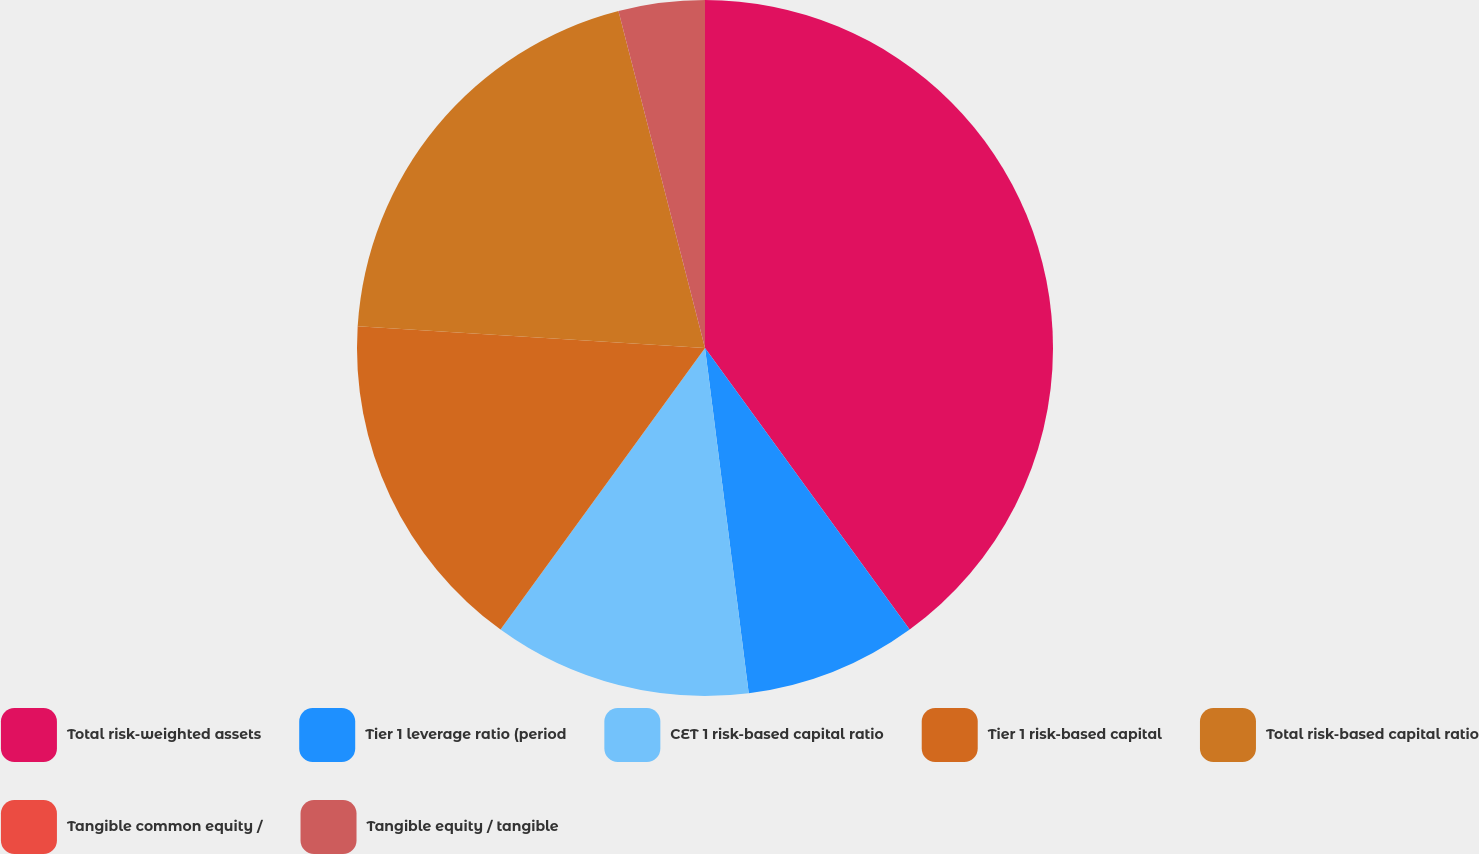Convert chart to OTSL. <chart><loc_0><loc_0><loc_500><loc_500><pie_chart><fcel>Total risk-weighted assets<fcel>Tier 1 leverage ratio (period<fcel>CET 1 risk-based capital ratio<fcel>Tier 1 risk-based capital<fcel>Total risk-based capital ratio<fcel>Tangible common equity /<fcel>Tangible equity / tangible<nl><fcel>39.99%<fcel>8.0%<fcel>12.0%<fcel>16.0%<fcel>20.0%<fcel>0.0%<fcel>4.0%<nl></chart> 